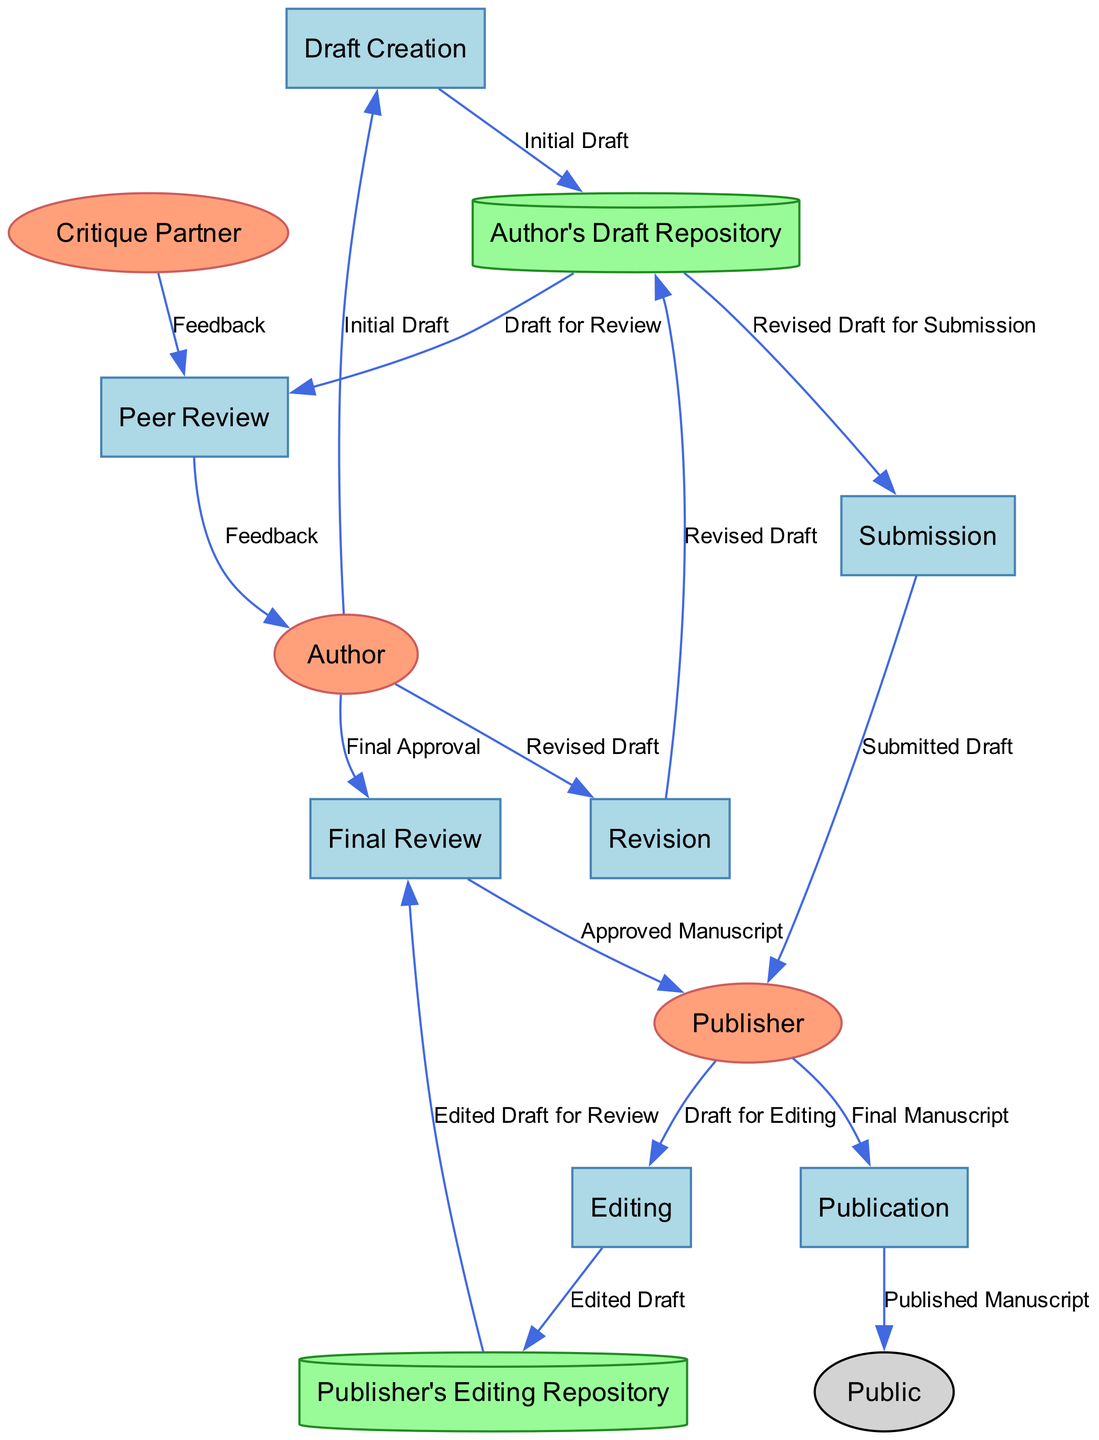What is the first process in the workflow? The first process is represented by the node labeled "Draft Creation." This can be identified as the starting point when following the flow in the diagram.
Answer: Draft Creation How many external entities are present in the diagram? By counting the distinct nodes labeled as external entities, we find that there are three external entities: Author, Critique Partner, and Publisher.
Answer: 3 Which process follows the Revision process? The diagram shows a directed flow where the Revision process is followed by the Submission process, indicated by an arrow leading to Submission.
Answer: Submission What type of storage is used for the author's drafts? The diagram identifies the node labeled "Author's Draft Repository" as a location for storing drafts. The specific shape representing this data store is a cylinder, which is typical for databases or repositories.
Answer: Cylinder What data flow occurs from Peer Review to Author? The data flow from Peer Review to Author includes the transfer labeled "Feedback," where feedback about the draft is sent back to the author. This can be easily found by examining the connection between these two nodes.
Answer: Feedback In which process does the author provide final approval? The author gives final approval in the "Final Review" process. This is indicated in the diagram as the author is shown sending data for approval to this specific process.
Answer: Final Review What is the last step in the workflow? The last step in the workflow is the "Publication" process. This is derived from tracing the final flows that end with the publication of the manuscript.
Answer: Publication Which data store holds the edited drafts? The node for edited drafts is labeled "Publisher's Editing Repository," which is shown clearly in the diagram as a cylinder. This specific storage type indicates it's a repository for edited versions of drafts.
Answer: Publisher's Editing Repository What feedback is provided by the Critique Partner? The Critique Partner provides "Feedback" on the draft during the Peer Review process, as indicated by the data flow labeled accordingly in the diagram. This feedback is crucial for the author's revision stage.
Answer: Feedback 